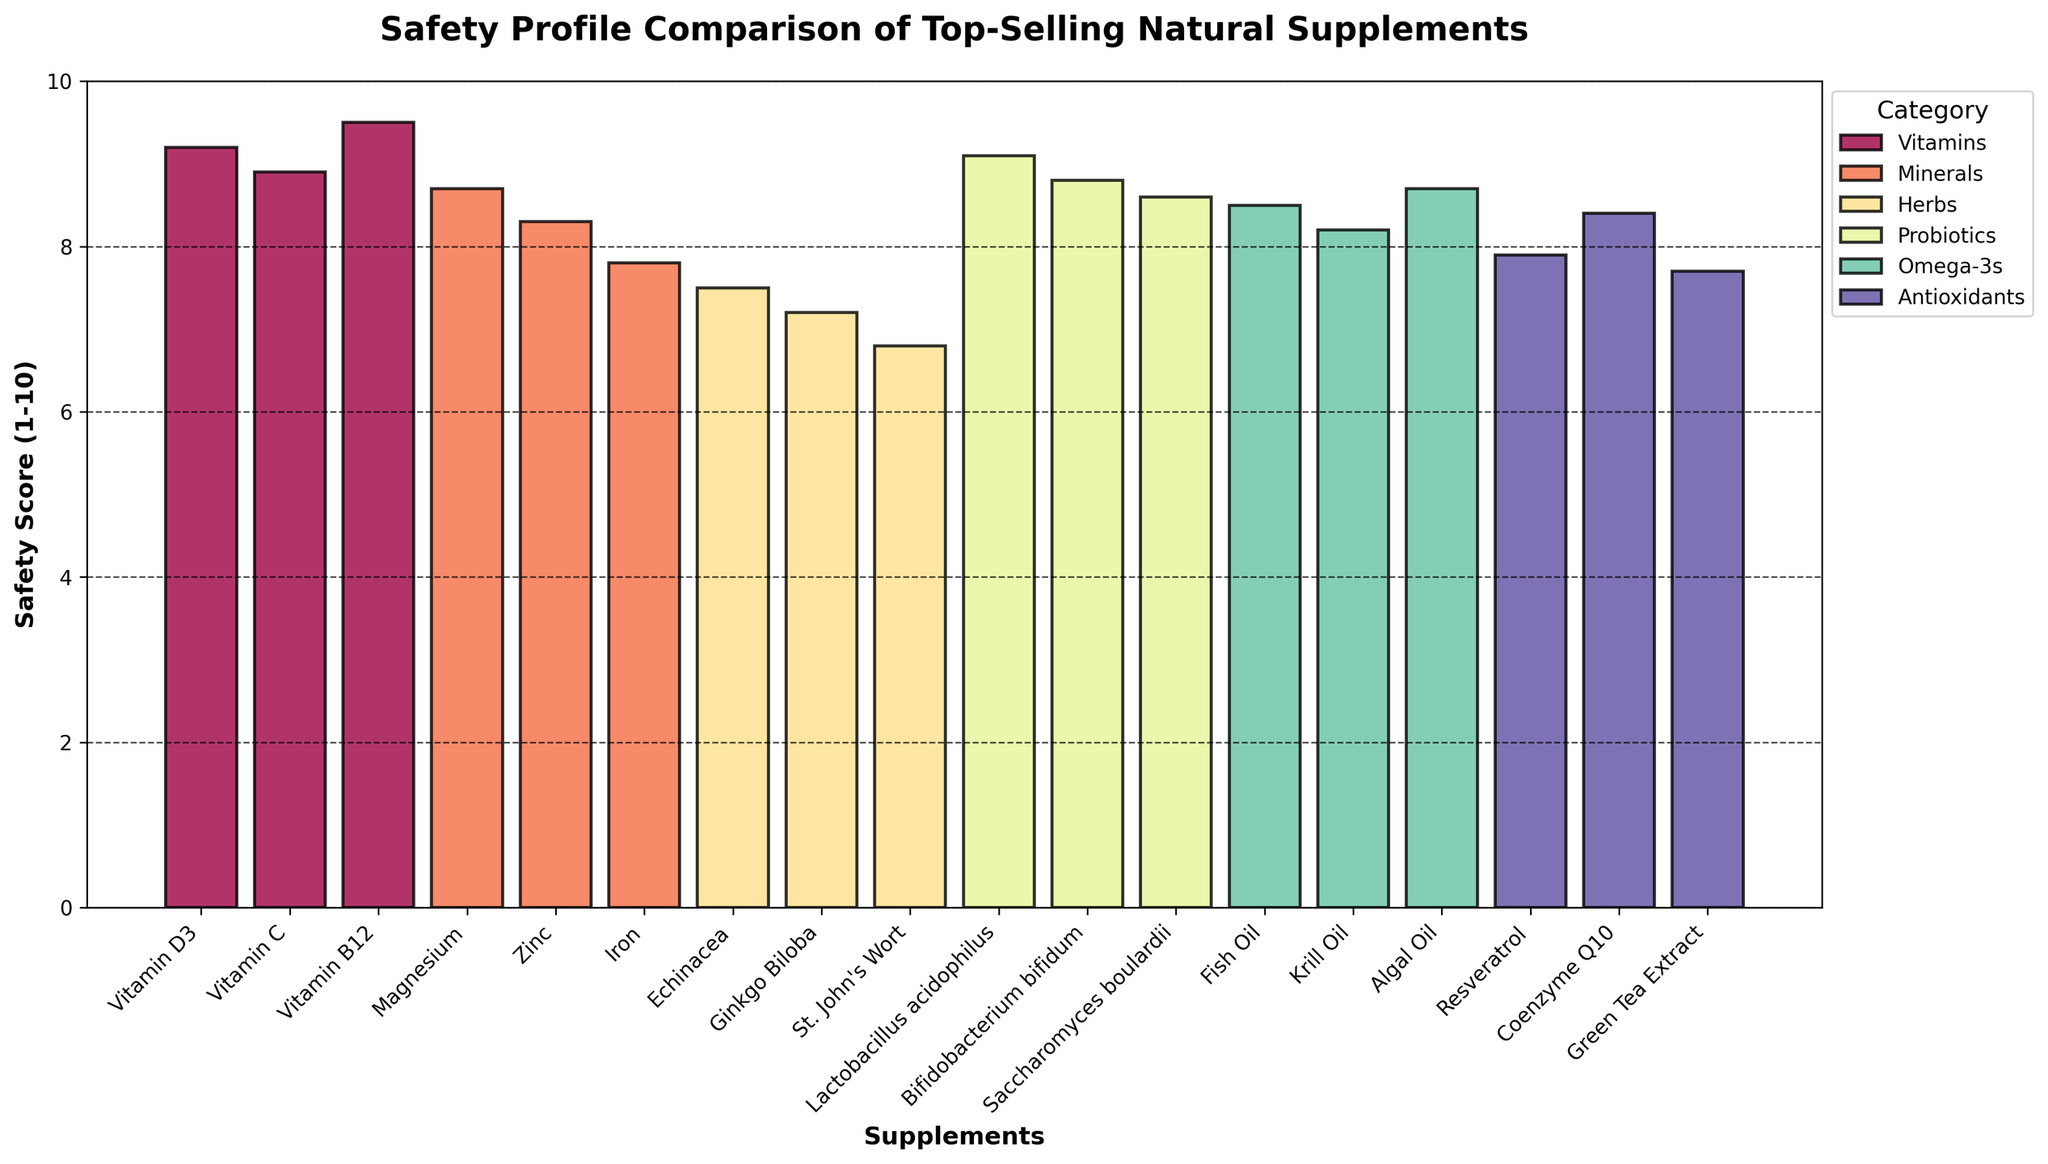What is the highest safety score among all supplements? Identify the bar with the maximum height across all categories. Vitamin B12 has the highest safety score of 9.5.
Answer: 9.5 Which category has the highest average safety score? Calculate the average safety score for each category, and compare the averages. Vitamins: (9.2 + 8.9 + 9.5) / 3 = 9.2; Minerals: (8.7 + 8.3 + 7.8) / 3 = 8.27; Herbs: (7.5 + 7.2 + 6.8) / 3 = 7.17; Probiotics: (9.1 + 8.8 + 8.6) /3 = 8.83; Omega-3s: (8.5 + 8.2 + 8.7) / 3 = 8.47; Antioxidants: (7.9 + 8.4 + 7.7) / 3 = 8.0. The category Vitamins has the highest average safety score of 9.2.
Answer: Vitamins What is the difference in safety score between the safest and least safe herbal supplement? Identify the highest and lowest safety scores within the Herbs category. Echinacea: 7.5; Ginkgo Biloba: 7.2; St. John's Wort: 6.8. Difference: 7.5 - 6.8 = 0.7
Answer: 0.7 Which supplement has a higher safety score: Fish Oil or Krill Oil? Compare the heights of the bars for Fish Oil and Krill Oil in the Omega-3s category. Fish Oil: 8.5; Krill Oil: 8.2. Fish Oil has a higher safety score than Krill Oil.
Answer: Fish Oil How many supplements have a safety score higher than 8.5? Count the bars with a height representing a safety score greater than 8.5. Vitamin D3: 9.2; Vitamin B12: 9.5; Lactobacillus acidophilus: 9.1; Vitamin C: 8.9; Bifidobacterium bifidum: 8.8; Algal Oil: 8.7; Magnesium: 8.7; Saccharomyces boulardii: 8.6. There are 8 supplements with a safety score higher than 8.5.
Answer: 8 Which category has the most supplements with a safety score above 8? Count the number of supplements with a safety score over 8 within each category. Vitamins: 3; Minerals: 2; Herbs: 0; Probiotics: 3; Omega-3s: 2; Antioxidants: 1. The categories Vitamins and Probiotics each have 3 supplements with a safety score above 8.
Answer: Vitamins and Probiotics What is the average safety score of Omega-3 supplements? Calculate the average safety score for Omega-3s. Fish Oil: 8.5; Krill Oil: 8.2; Algal Oil: 8.7. Average: (8.5 + 8.2 + 8.7) / 3 = 8.47
Answer: 8.47 Which antioxidant has the lowest safety score, and what is it? Compare the heights of bars within the Antioxidants category. Resveratrol: 7.9; Coenzyme Q10: 8.4; Green Tea Extract: 7.7. Green Tea Extract has the lowest safety score, which is 7.7.
Answer: Green Tea Extract, 7.7 Is the safety score of Iron higher or lower than that of Coenzyme Q10? Compare the heights of the Iron bar in Minerals and Coenzyme Q10 bar in Antioxidants. Iron: 7.8; Coenzyme Q10: 8.4. Iron has a lower safety score than Coenzyme Q10.
Answer: Lower 